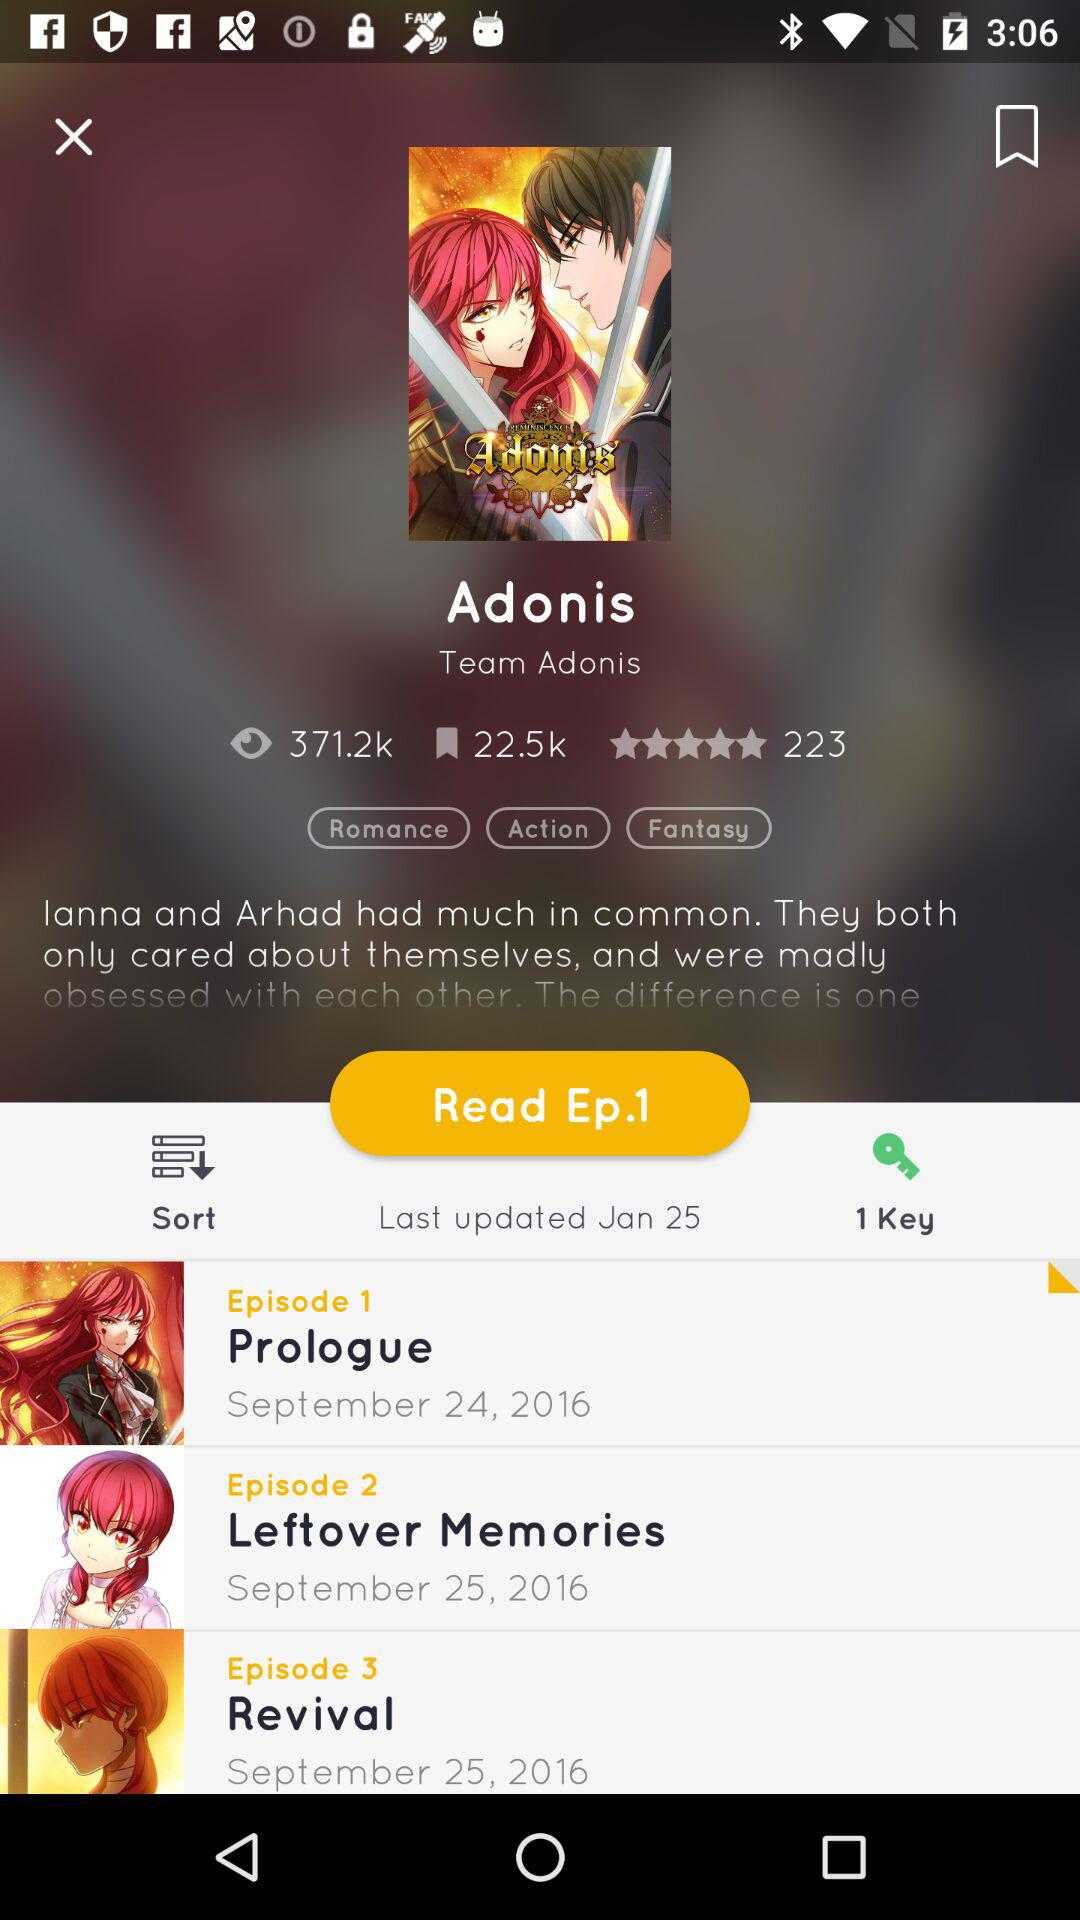How many bookmarks are there? There are 22.5K bookmarks. 